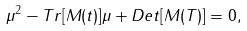<formula> <loc_0><loc_0><loc_500><loc_500>\mu ^ { 2 } - T r [ M ( t ) ] \mu + D e t [ M ( T ) ] = 0 ,</formula> 